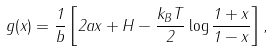Convert formula to latex. <formula><loc_0><loc_0><loc_500><loc_500>g ( x ) = \frac { 1 } { b } \left [ 2 a x + H - \frac { k _ { B } T } { 2 } \log \frac { 1 + x } { 1 - x } \right ] ,</formula> 